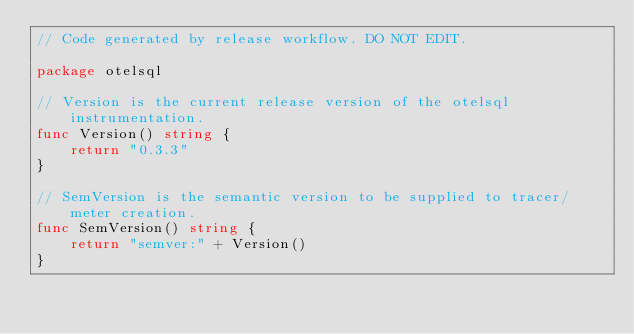<code> <loc_0><loc_0><loc_500><loc_500><_Go_>// Code generated by release workflow. DO NOT EDIT.

package otelsql

// Version is the current release version of the otelsql instrumentation.
func Version() string {
	return "0.3.3"
}

// SemVersion is the semantic version to be supplied to tracer/meter creation.
func SemVersion() string {
	return "semver:" + Version()
}
</code> 